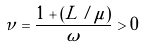Convert formula to latex. <formula><loc_0><loc_0><loc_500><loc_500>\nu = \frac { 1 + ( L / \mu ) } { \omega } > 0</formula> 